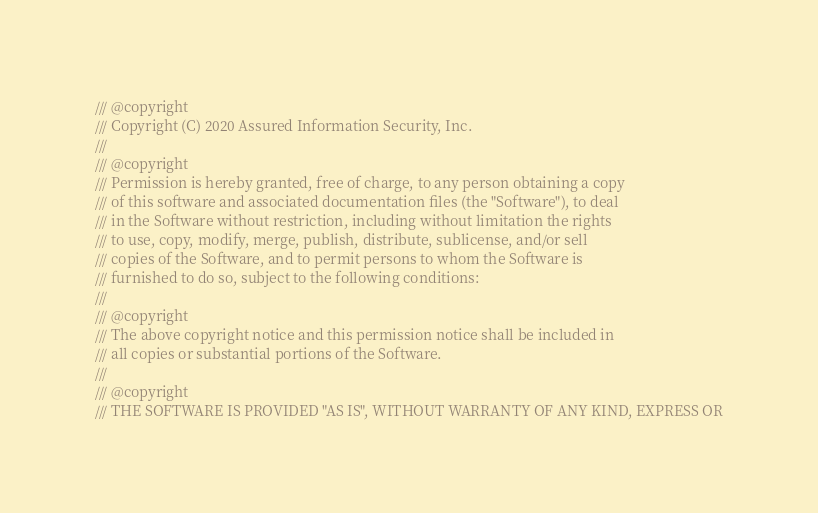Convert code to text. <code><loc_0><loc_0><loc_500><loc_500><_C++_>/// @copyright
/// Copyright (C) 2020 Assured Information Security, Inc.
///
/// @copyright
/// Permission is hereby granted, free of charge, to any person obtaining a copy
/// of this software and associated documentation files (the "Software"), to deal
/// in the Software without restriction, including without limitation the rights
/// to use, copy, modify, merge, publish, distribute, sublicense, and/or sell
/// copies of the Software, and to permit persons to whom the Software is
/// furnished to do so, subject to the following conditions:
///
/// @copyright
/// The above copyright notice and this permission notice shall be included in
/// all copies or substantial portions of the Software.
///
/// @copyright
/// THE SOFTWARE IS PROVIDED "AS IS", WITHOUT WARRANTY OF ANY KIND, EXPRESS OR</code> 